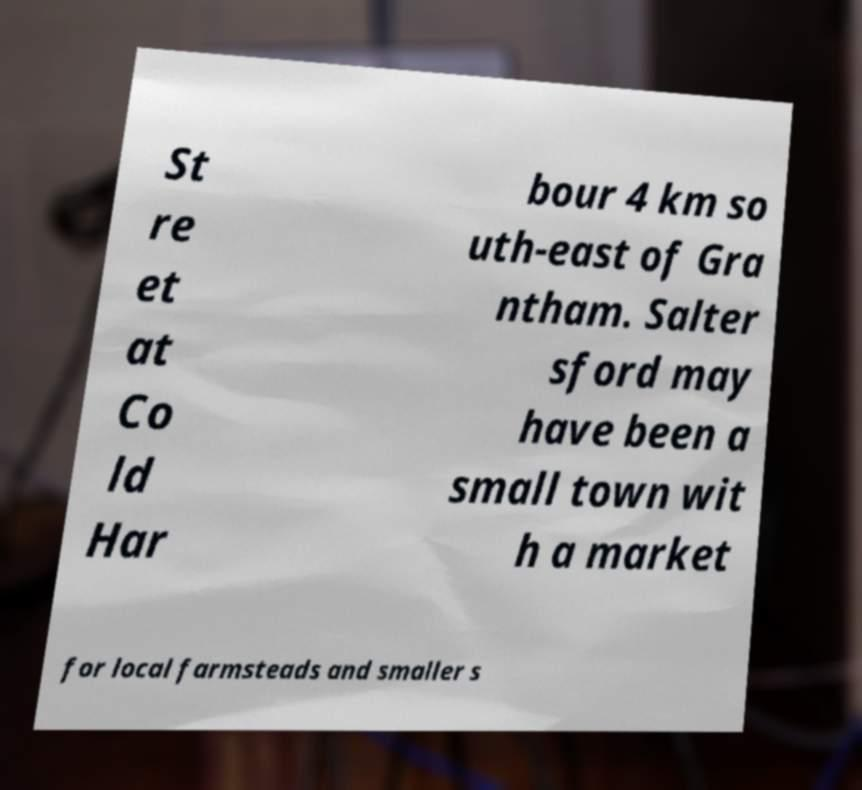Could you assist in decoding the text presented in this image and type it out clearly? St re et at Co ld Har bour 4 km so uth-east of Gra ntham. Salter sford may have been a small town wit h a market for local farmsteads and smaller s 